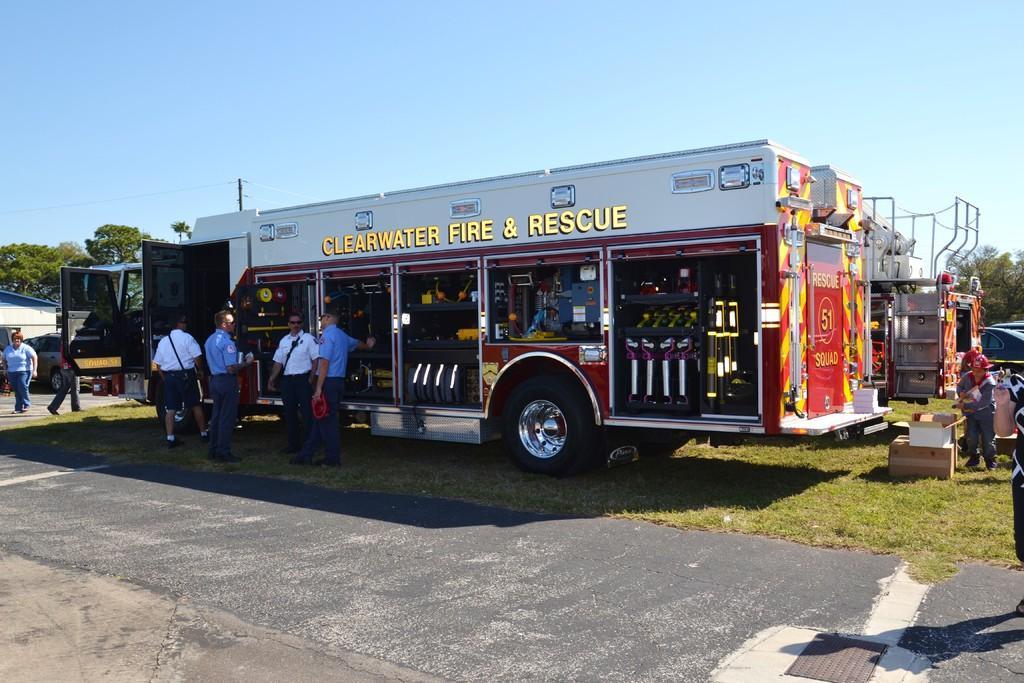In one or two sentences, can you explain what this image depicts? In the picture we can see a fire engine vehicle and near it, we can see four people are standing with uniforms and beside the vehicle we can see another two fire engine vehicles on the grass path and in front of the vehicles we can see some cars are parked and in the background we can see some trees and sky. 